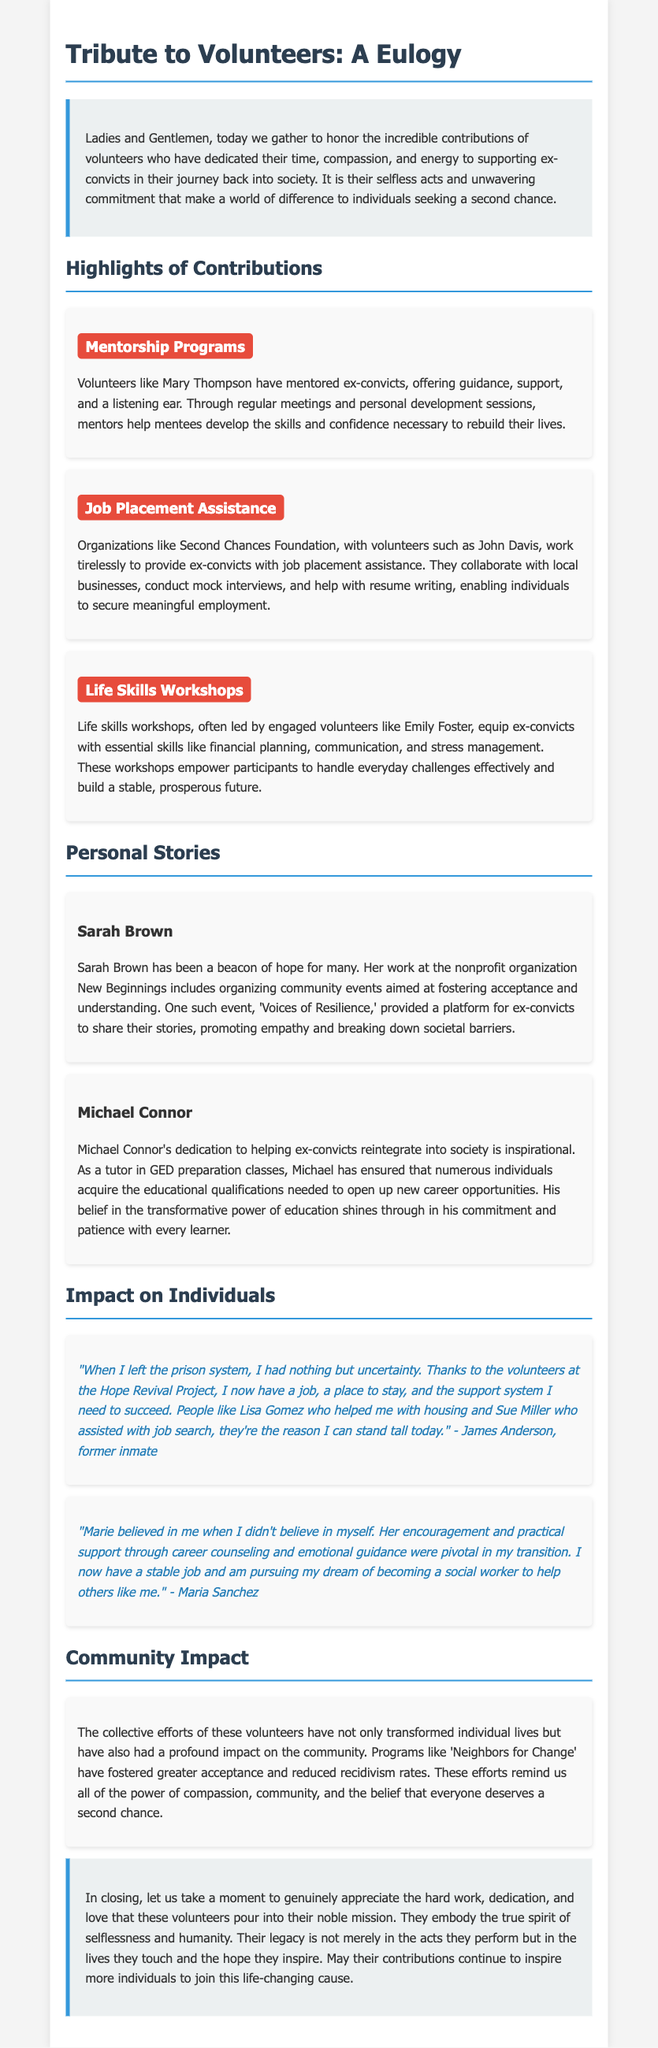What is the main purpose of the eulogy? The eulogy is dedicated to honoring volunteers who support ex-convicts in their re-entry process.
Answer: honoring volunteers Who is highlighted for leading Life Skills Workshops? Emily Foster is mentioned as a volunteer leading these workshops.
Answer: Emily Foster What event did Sarah Brown organize? Sarah Brown organized a community event called 'Voices of Resilience.'
Answer: 'Voices of Resilience' Which organization worked with John Davis on job placement? The organization mentioned is the Second Chances Foundation.
Answer: Second Chances Foundation What essential skills do Life Skills Workshops cover? The workshops cover financial planning, communication, and stress management.
Answer: financial planning, communication, and stress management How did the volunteers impact recidivism rates? Their efforts have helped reduce recidivism rates in the community.
Answer: reduced recidivism rates What is the quote from James Anderson expressing gratitude for? James Anderson's quote expresses gratitude for the support he received in finding a job and housing.
Answer: finding a job and housing What theme is emphasized in the conclusion of the eulogy? The conclusion emphasizes the themes of selflessness and humanity in the volunteers’ work.
Answer: selflessness and humanity 